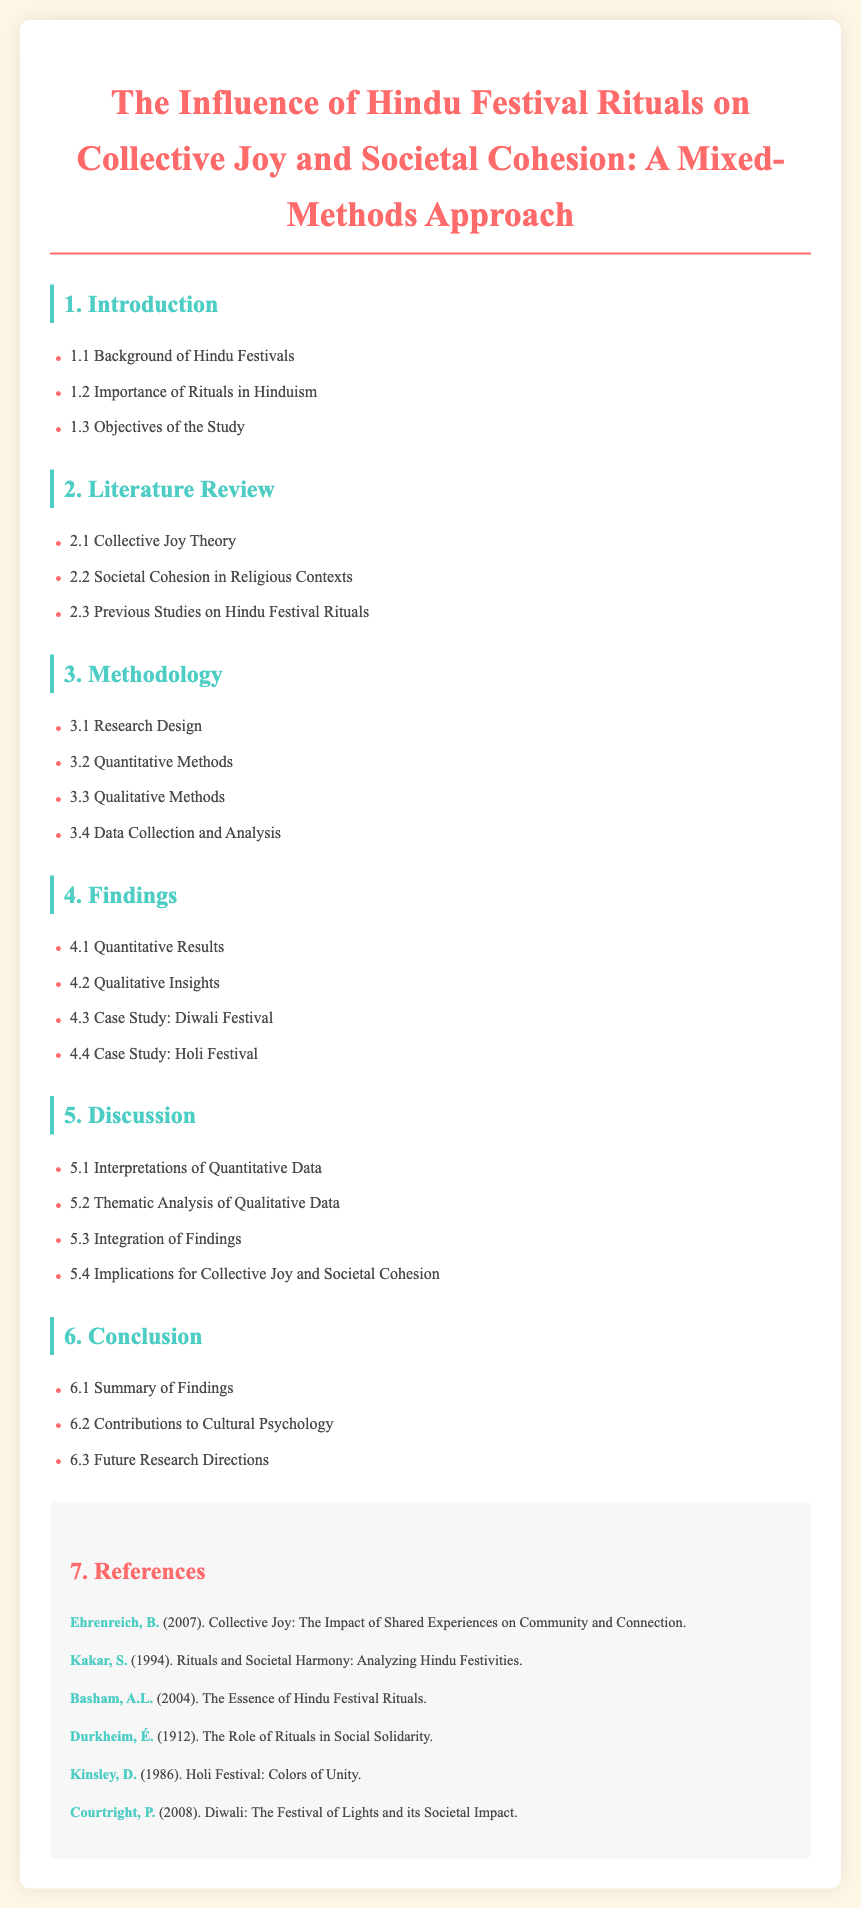what is the main title of the document? The main title summarizes the focus of the document, which is about Hindu festival rituals and their influence.
Answer: The Influence of Hindu Festival Rituals on Collective Joy and Societal Cohesion: A Mixed-Methods Approach how many sections are in the findings? The number of sections listed in the findings provides insight into the depth of research and analysis.
Answer: Four what is the case study mentioned for the Holi Festival? The case study specifically related to this festival provides detailed analysis and findings.
Answer: Case Study: Holi Festival who is the author of the work discussing the Role of Rituals in Social Solidarity? The author related to this key concept highlights the significance of rituals in societal contexts.
Answer: Émile Durkheim what are the implications discussed in the document? The implications point to the broader effects that the study's findings may have on society and psychology.
Answer: Implications for Collective Joy and Societal Cohesion what is one of the objectives of the study? The objectives reflect the intent of the research regarding the impact of rituals on groups.
Answer: Objectives of the Study how many qualitative methods are mentioned in the methodology? The number of qualitative methods used indicates the variety of approaches taken in the research design.
Answer: One who wrote about the essence of Hindu festival rituals? The author's work offers insights into the fundamental aspects of these rituals in Hinduism.
Answer: A.L. Basham 